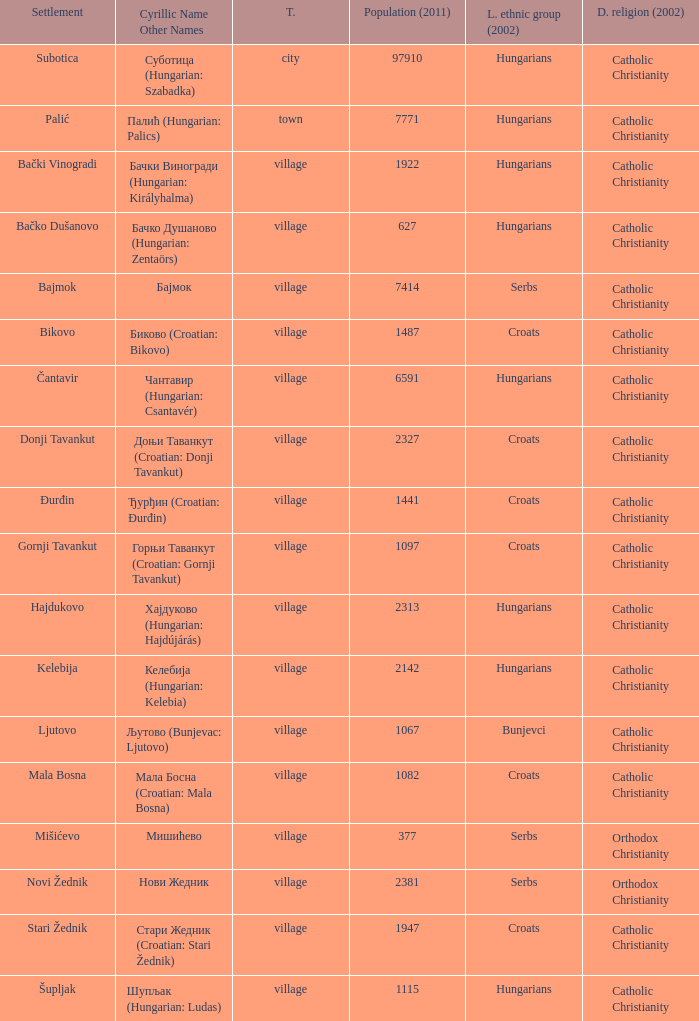How many settlements are named ђурђин (croatian: đurđin)? 1.0. 